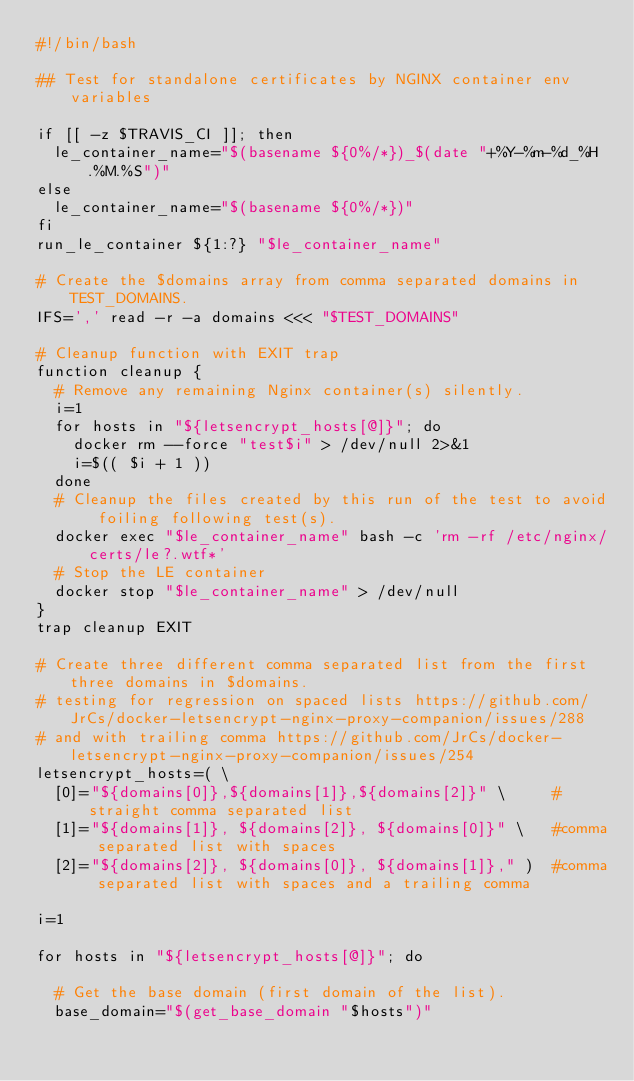Convert code to text. <code><loc_0><loc_0><loc_500><loc_500><_Bash_>#!/bin/bash

## Test for standalone certificates by NGINX container env variables

if [[ -z $TRAVIS_CI ]]; then
  le_container_name="$(basename ${0%/*})_$(date "+%Y-%m-%d_%H.%M.%S")"
else
  le_container_name="$(basename ${0%/*})"
fi
run_le_container ${1:?} "$le_container_name"

# Create the $domains array from comma separated domains in TEST_DOMAINS.
IFS=',' read -r -a domains <<< "$TEST_DOMAINS"

# Cleanup function with EXIT trap
function cleanup {
  # Remove any remaining Nginx container(s) silently.
  i=1
  for hosts in "${letsencrypt_hosts[@]}"; do
    docker rm --force "test$i" > /dev/null 2>&1
    i=$(( $i + 1 ))
  done
  # Cleanup the files created by this run of the test to avoid foiling following test(s).
  docker exec "$le_container_name" bash -c 'rm -rf /etc/nginx/certs/le?.wtf*'
  # Stop the LE container
  docker stop "$le_container_name" > /dev/null
}
trap cleanup EXIT

# Create three different comma separated list from the first three domains in $domains.
# testing for regression on spaced lists https://github.com/JrCs/docker-letsencrypt-nginx-proxy-companion/issues/288
# and with trailing comma https://github.com/JrCs/docker-letsencrypt-nginx-proxy-companion/issues/254
letsencrypt_hosts=( \
  [0]="${domains[0]},${domains[1]},${domains[2]}" \     #straight comma separated list
  [1]="${domains[1]}, ${domains[2]}, ${domains[0]}" \   #comma separated list with spaces
  [2]="${domains[2]}, ${domains[0]}, ${domains[1]}," )  #comma separated list with spaces and a trailing comma

i=1

for hosts in "${letsencrypt_hosts[@]}"; do

  # Get the base domain (first domain of the list).
  base_domain="$(get_base_domain "$hosts")"</code> 